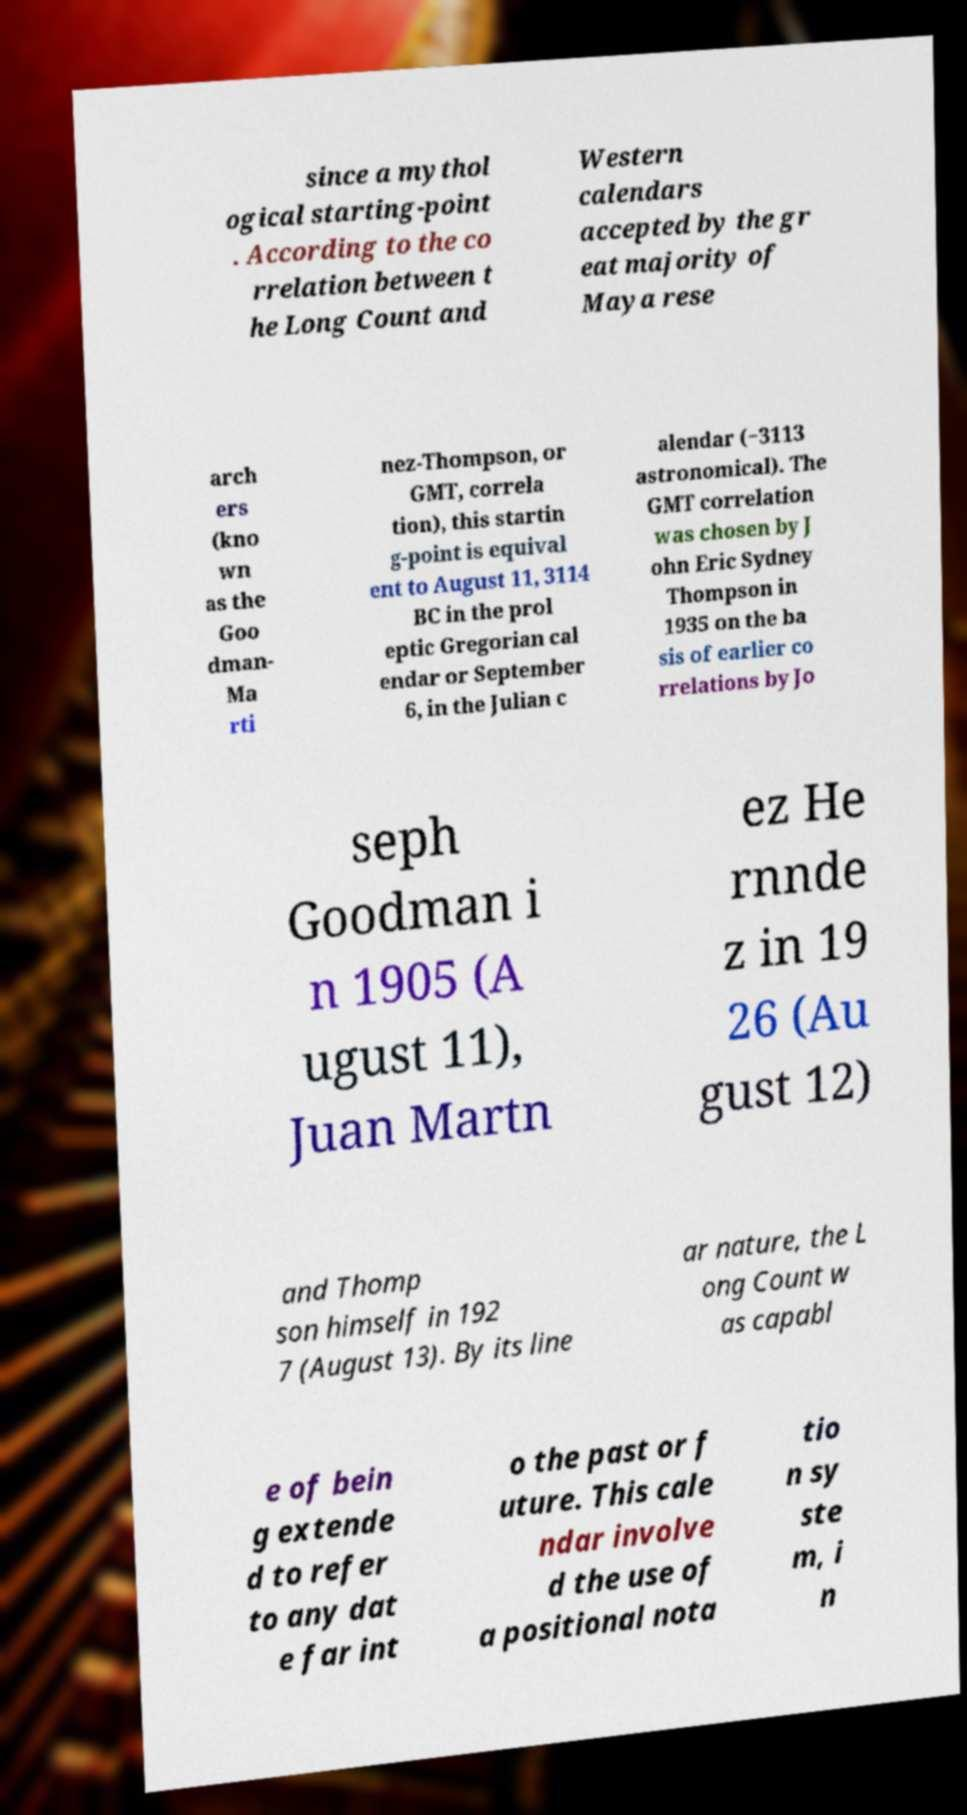Please read and relay the text visible in this image. What does it say? since a mythol ogical starting-point . According to the co rrelation between t he Long Count and Western calendars accepted by the gr eat majority of Maya rese arch ers (kno wn as the Goo dman- Ma rti nez-Thompson, or GMT, correla tion), this startin g-point is equival ent to August 11, 3114 BC in the prol eptic Gregorian cal endar or September 6, in the Julian c alendar (−3113 astronomical). The GMT correlation was chosen by J ohn Eric Sydney Thompson in 1935 on the ba sis of earlier co rrelations by Jo seph Goodman i n 1905 (A ugust 11), Juan Martn ez He rnnde z in 19 26 (Au gust 12) and Thomp son himself in 192 7 (August 13). By its line ar nature, the L ong Count w as capabl e of bein g extende d to refer to any dat e far int o the past or f uture. This cale ndar involve d the use of a positional nota tio n sy ste m, i n 